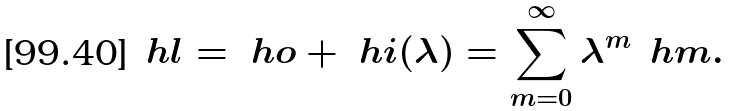<formula> <loc_0><loc_0><loc_500><loc_500>\ h l = \ h o + \ h i ( \lambda ) = \sum _ { m = 0 } ^ { \infty } \lambda ^ { m } \, \ h m .</formula> 